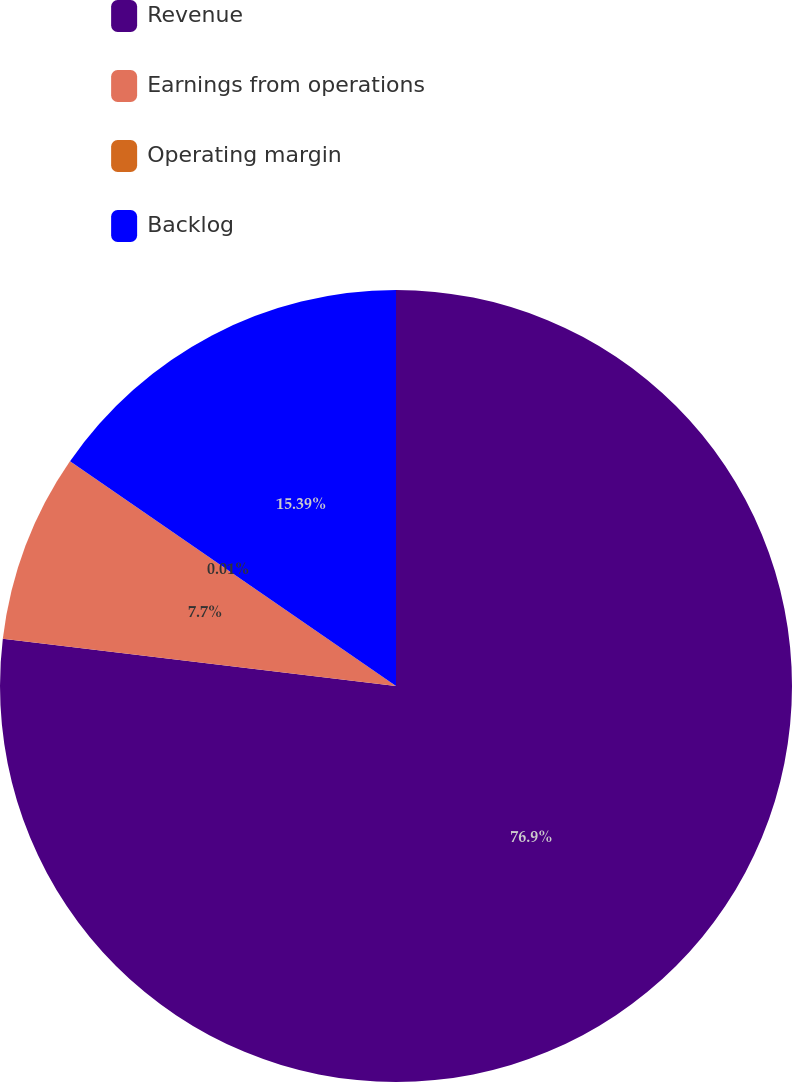Convert chart. <chart><loc_0><loc_0><loc_500><loc_500><pie_chart><fcel>Revenue<fcel>Earnings from operations<fcel>Operating margin<fcel>Backlog<nl><fcel>76.91%<fcel>7.7%<fcel>0.01%<fcel>15.39%<nl></chart> 